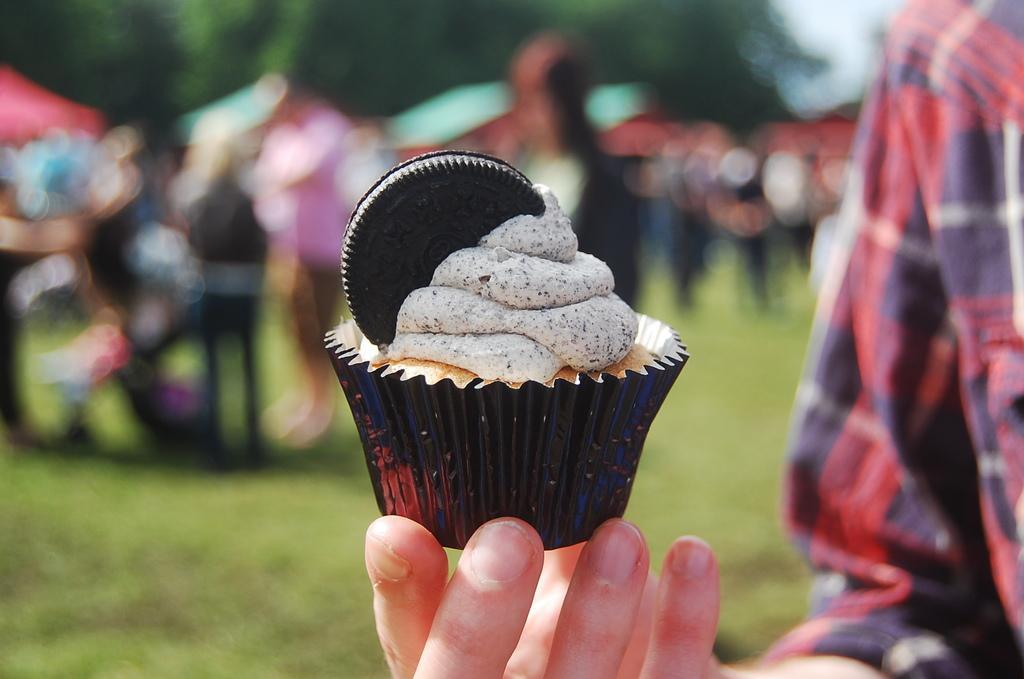Could you give a brief overview of what you see in this image? In the image we can see a person wearing clothes and the person is holding a cupcake in hand. Here we can see the grass and there are other people standing. Here we can see trees, sky and the background is blurred. 